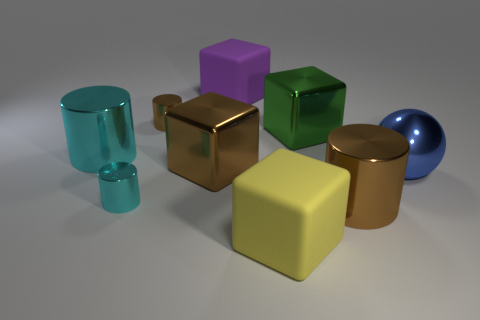Are there more large shiny spheres than cylinders?
Give a very brief answer. No. How many objects are either small objects or green metallic things that are behind the large blue thing?
Give a very brief answer. 3. What number of other objects are there of the same shape as the large blue shiny thing?
Your answer should be very brief. 0. Is the number of metal cylinders right of the large brown cylinder less than the number of brown cylinders on the right side of the green metallic object?
Provide a short and direct response. Yes. There is a purple object that is the same material as the yellow cube; what is its shape?
Offer a terse response. Cube. Is there anything else that is the same color as the large shiny sphere?
Give a very brief answer. No. There is a large cylinder in front of the cyan cylinder in front of the blue metal sphere; what color is it?
Provide a short and direct response. Brown. What material is the big purple block to the right of the cyan thing behind the big brown object that is on the left side of the big green shiny thing?
Provide a succinct answer. Rubber. How many brown objects are the same size as the metallic ball?
Your answer should be very brief. 2. What is the large thing that is both on the left side of the purple rubber block and to the right of the big cyan metallic object made of?
Make the answer very short. Metal. 